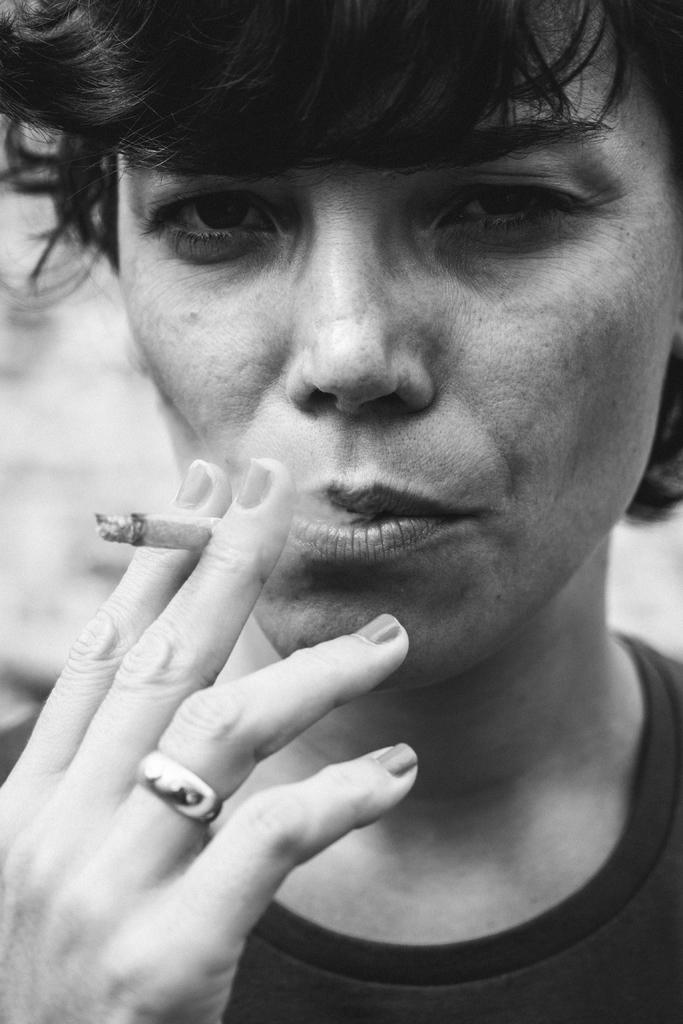What is the main subject of the image? There is a person in the image. What is the person holding in the image? The person is holding a cigar with two fingers. Can you describe any jewelry the person is wearing? The person has a ring on their ring finger. How many bananas are being held by the person in the image? There are no bananas present in the image; the person is holding a cigar. Can you tell me how many friends are visible in the image? There is no reference to friends or any other people in the image, only the person holding a cigar. 